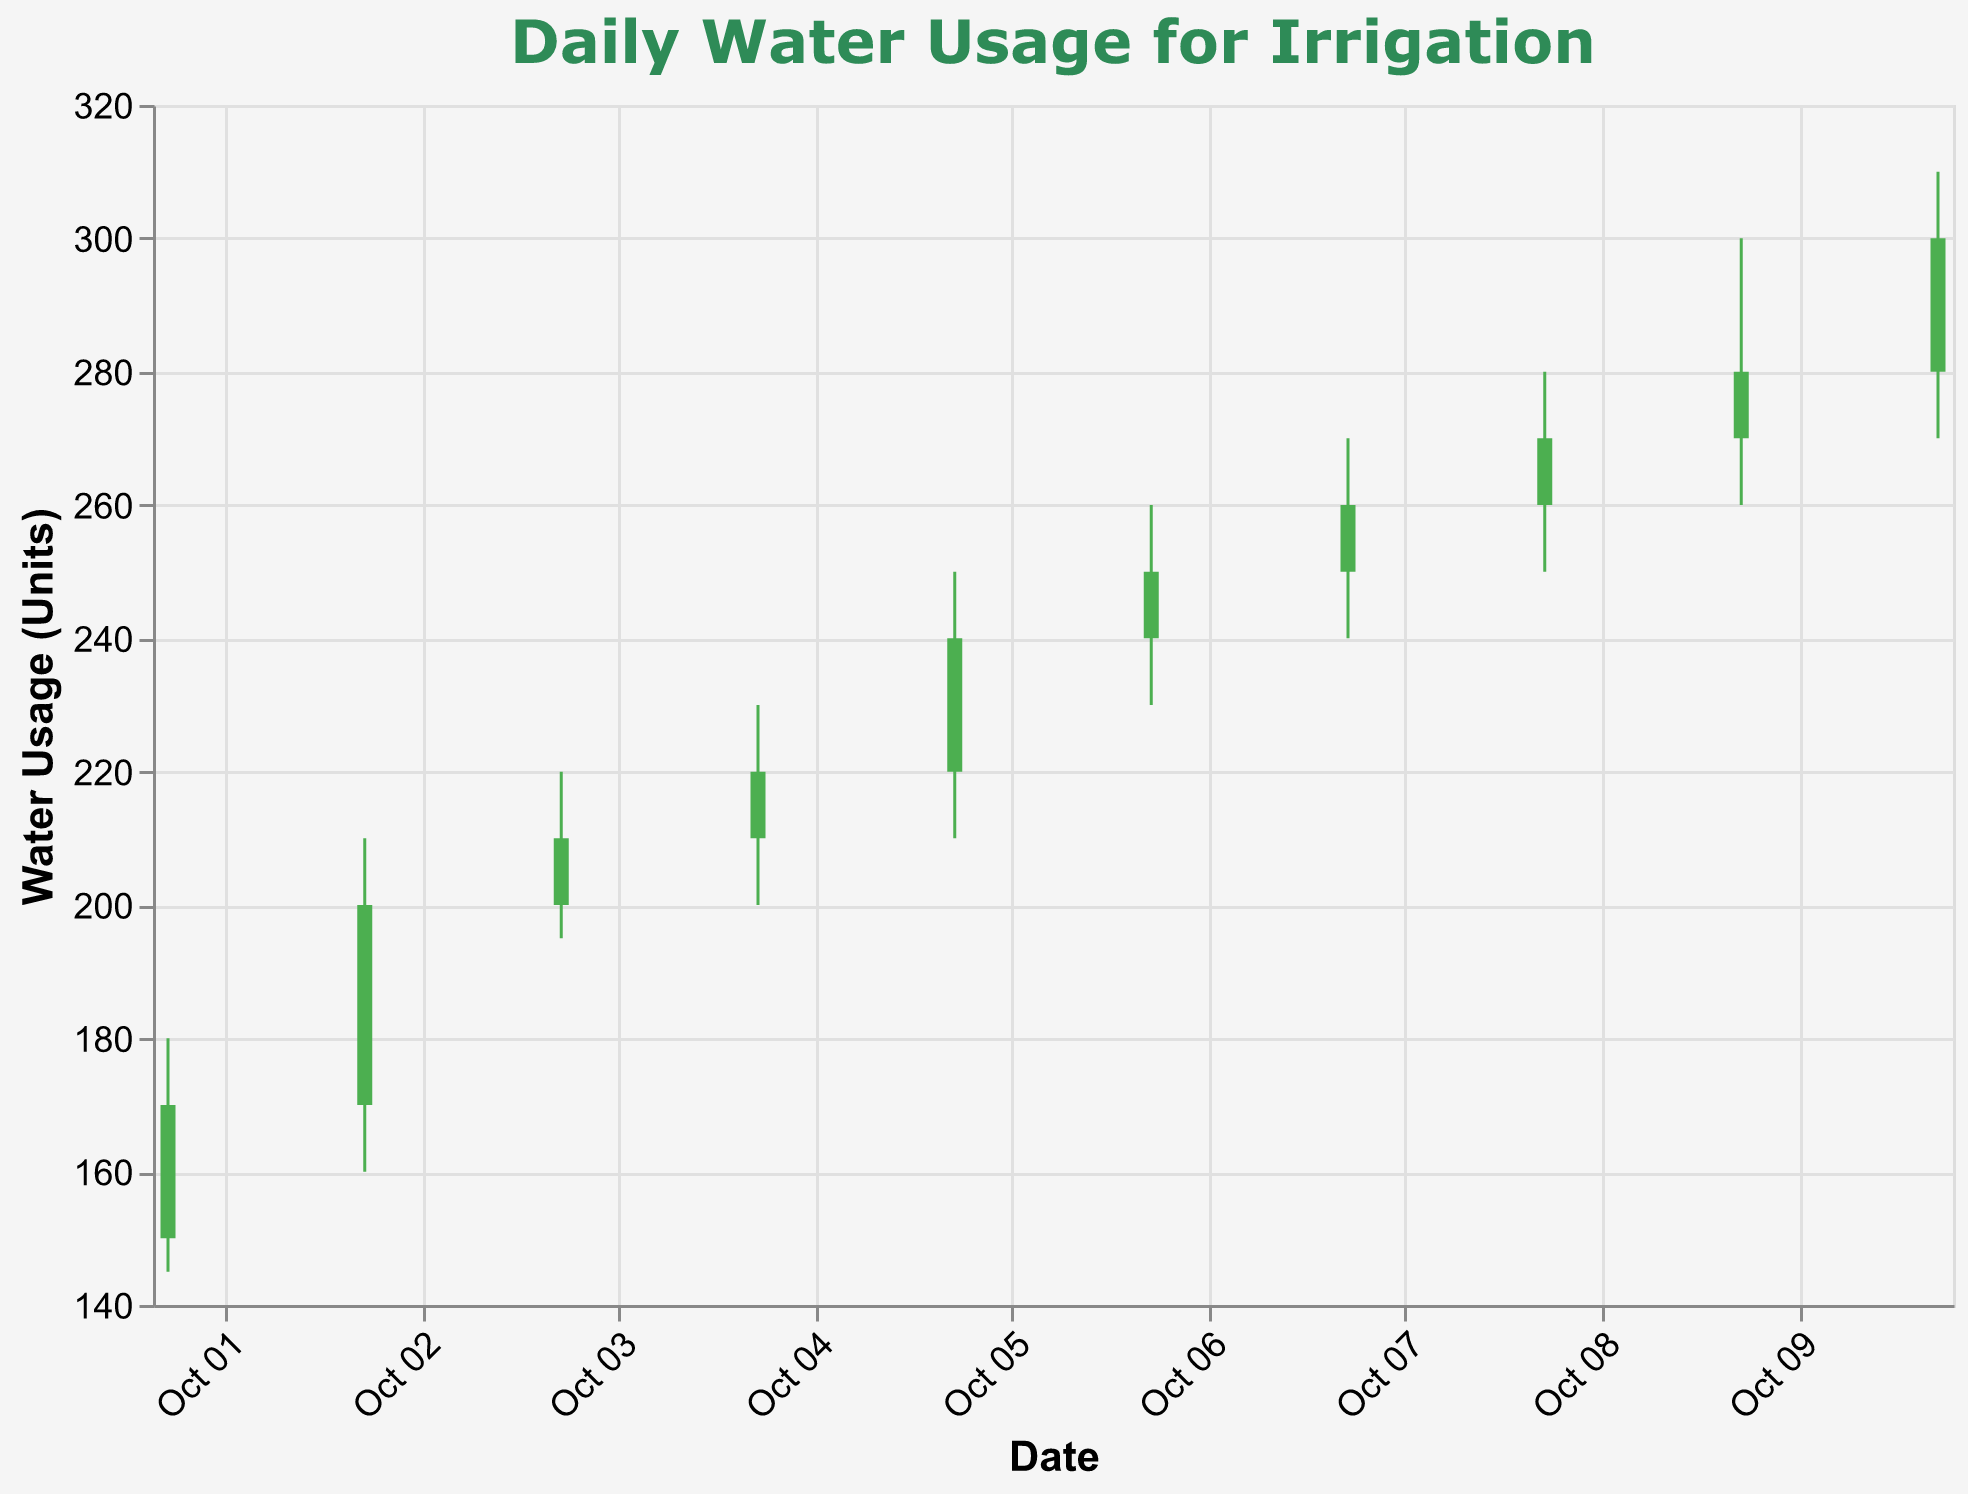What's the title of the figure? The title of the figure is placed prominently at the top and reads "Daily Water Usage for Irrigation".
Answer: Daily Water Usage for Irrigation How many days are represented in the figure? The x-axis displays dates from "2023-10-01" to "2023-10-10", indicating there are 10 days represented in total.
Answer: 10 days On which day was the highest water usage recorded? The highest water usage is indicated by the highest "High" value. "2023-10-10" has a high of 310 units.
Answer: 2023-10-10 How can you identify if a day's water usage increased or decreased? If the candlestick is green (#4CAF50), the water usage increased (Open < Close); if it's red (#F44336), the water usage decreased (Open > Close).
Answer: Green for increase, red for decrease On October 3, did the water usage increase or decrease, and by how much? The candlestick for October 3 is green, and the Close value (210) is higher than the Open value (200), indicating an increase by 210 - 200 = 10 units.
Answer: Increase by 10 units What is the range of water usage on October 6? The range is the difference between the High and Low values for October 6. The range is 260 - 230 = 30 units.
Answer: 30 units Which day shows the smallest range in water usage? The range is the difference between High and Low. For each day: 
- Oct 1: 180-145=35
- Oct 2: 210-160=50
- Oct 3: 220-195=25
- Oct 4: 230-200=30
- Oct 5: 250-210=40
- Oct 6: 260-230=30
- Oct 7: 270-240=30
- Oct 8: 280-250=30
- Oct 9: 300-260=40
- Oct 10: 310-270=40
So the smallest range is on October 3 with a range of 25 units.
Answer: October 3 How much did the water usage increase from October 1 to October 10? Compare the Close values of October 1 (170) and October 10 (300). The increase is 300 - 170 = 130 units.
Answer: 130 units Which days show a decrease in water usage? Days with red candlesticks indicate a decrease. No day has a red candlestick, so there's no day with a decrease in water usage.
Answer: None 